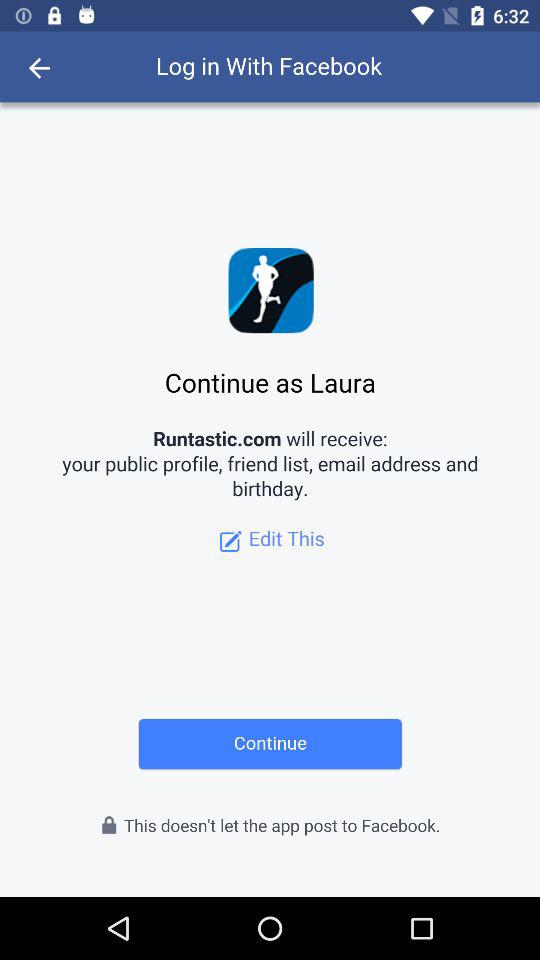Which option is selected?
When the provided information is insufficient, respond with <no answer>. <no answer> 